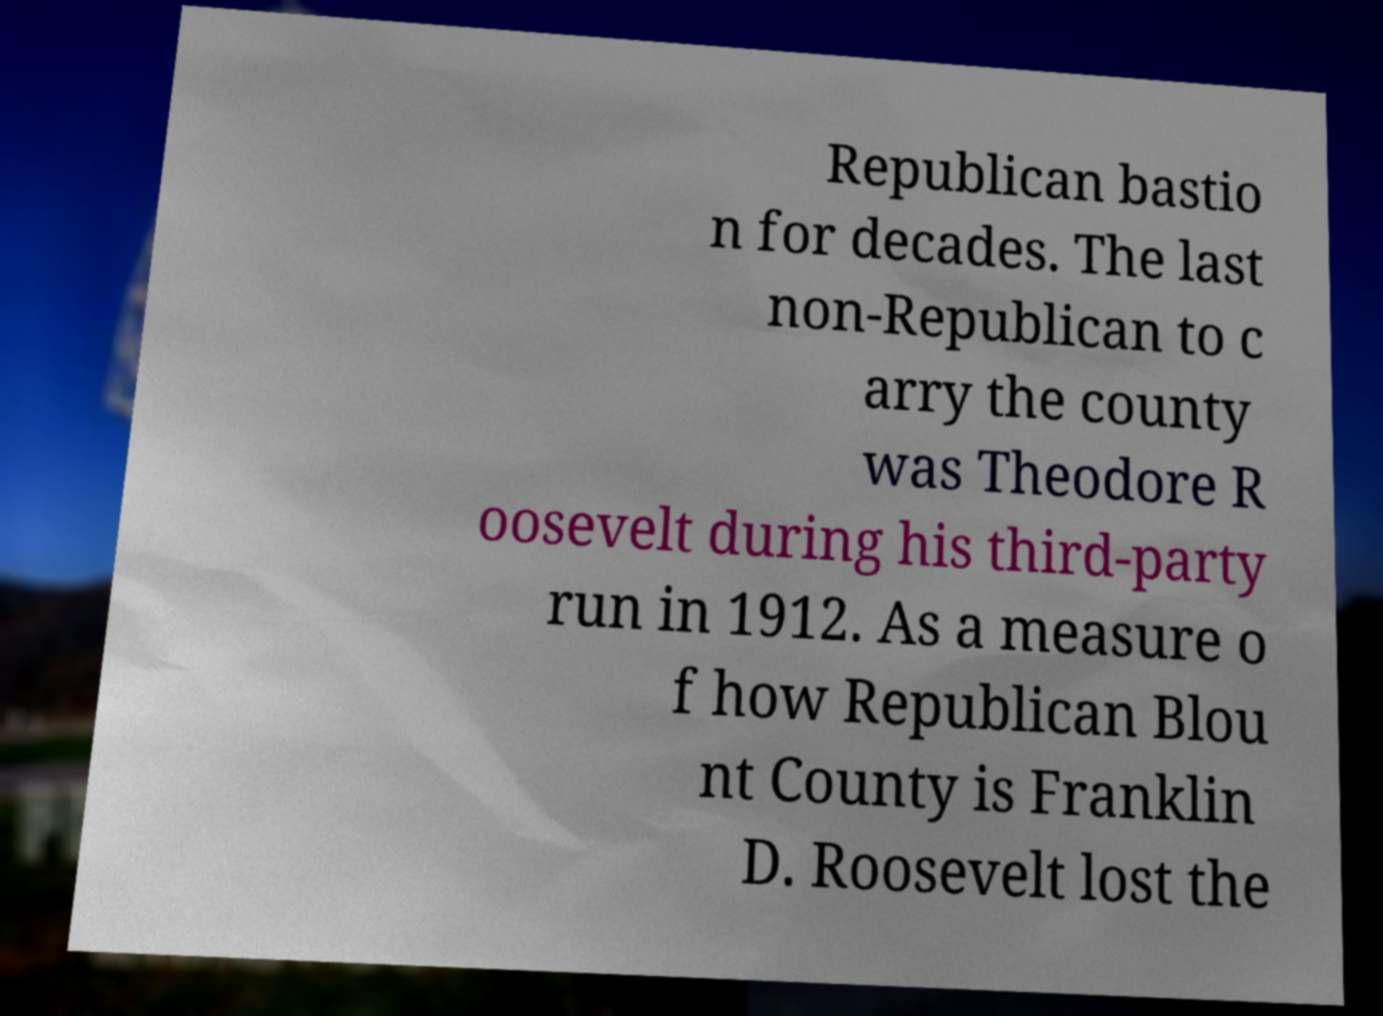For documentation purposes, I need the text within this image transcribed. Could you provide that? Republican bastio n for decades. The last non-Republican to c arry the county was Theodore R oosevelt during his third-party run in 1912. As a measure o f how Republican Blou nt County is Franklin D. Roosevelt lost the 